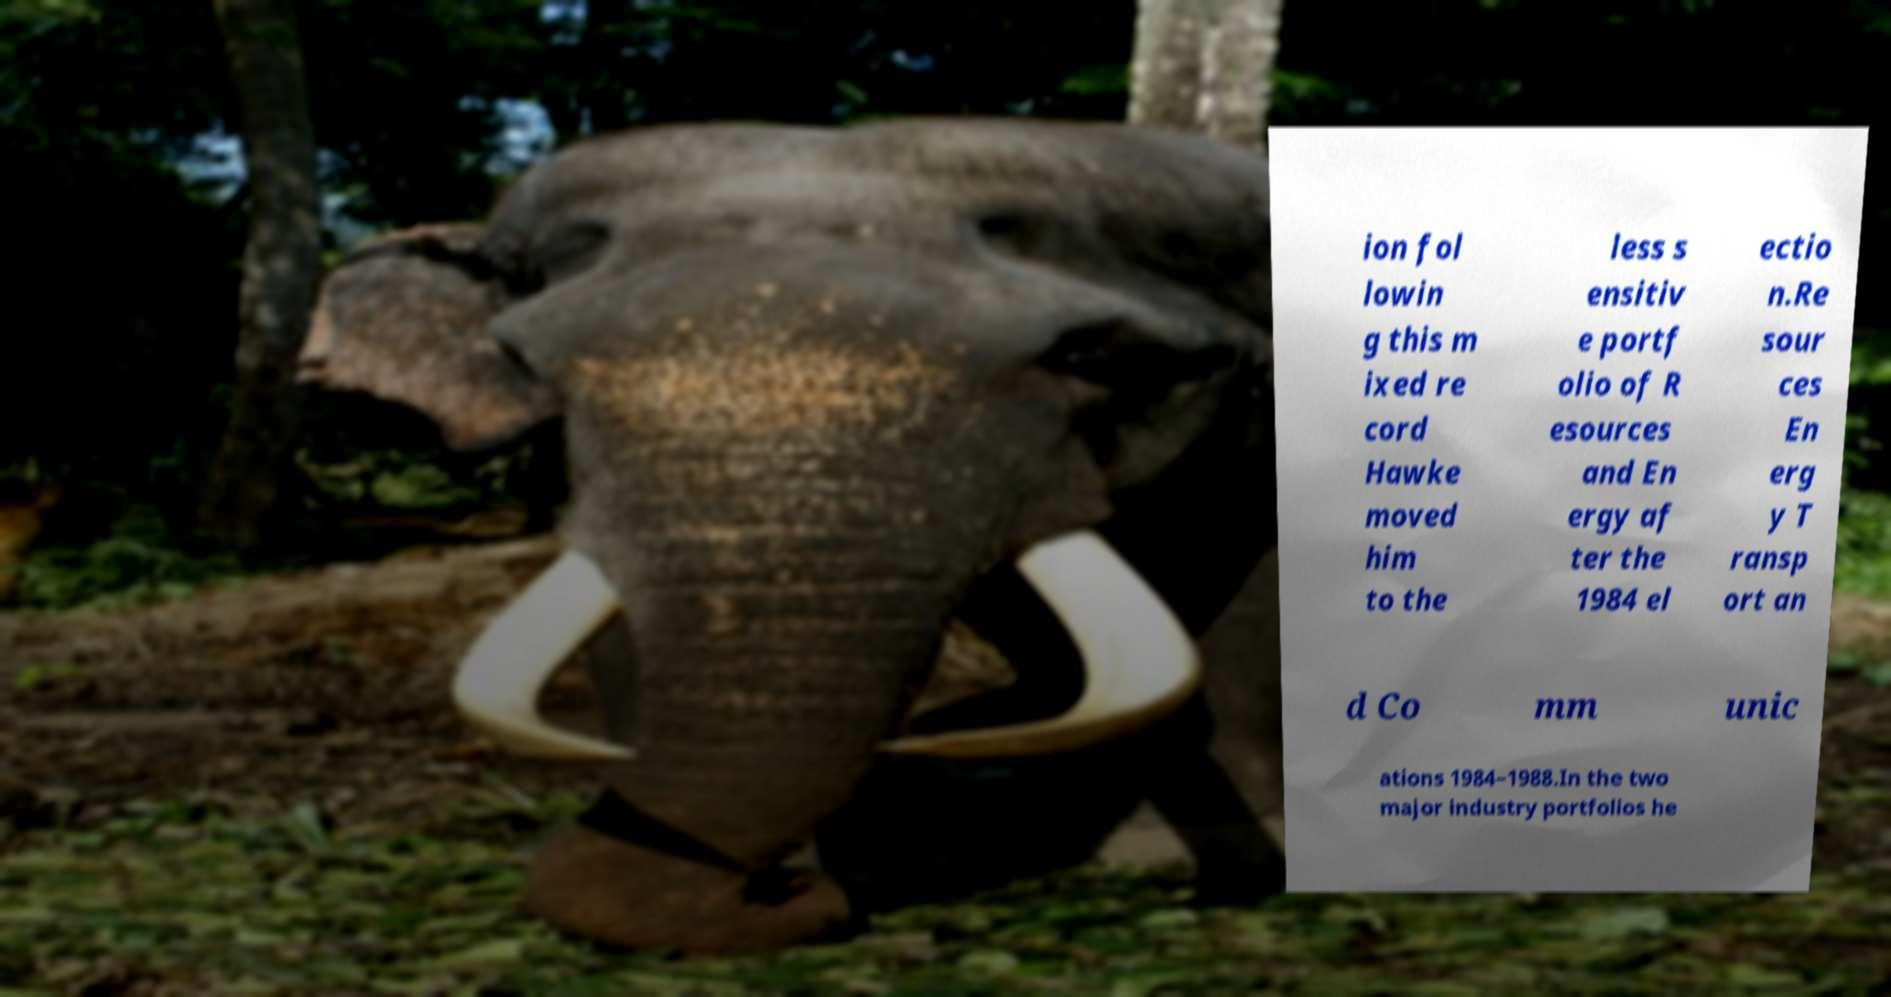I need the written content from this picture converted into text. Can you do that? ion fol lowin g this m ixed re cord Hawke moved him to the less s ensitiv e portf olio of R esources and En ergy af ter the 1984 el ectio n.Re sour ces En erg y T ransp ort an d Co mm unic ations 1984–1988.In the two major industry portfolios he 